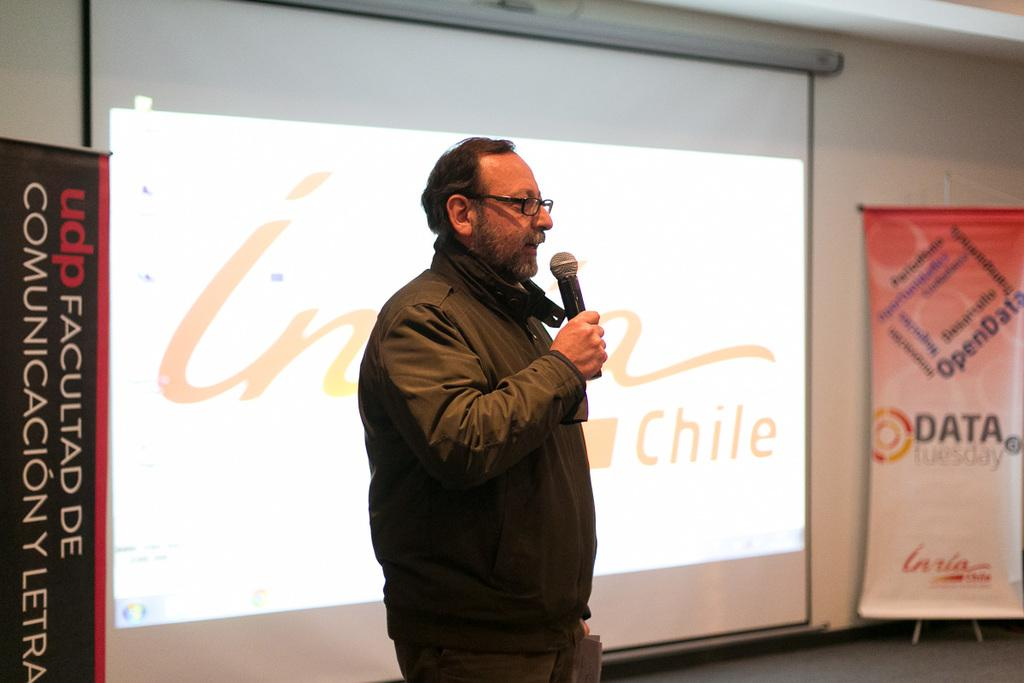Provide a one-sentence caption for the provided image. UDP Facultad De Communicacion Y Letra poster and Data Tuesday sign. 